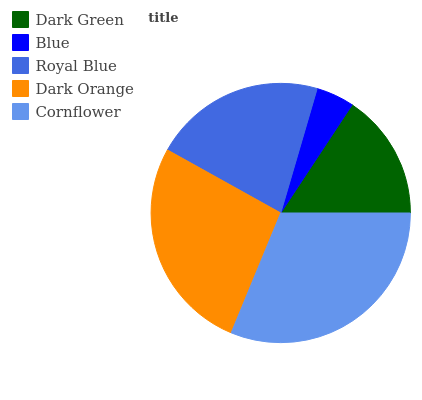Is Blue the minimum?
Answer yes or no. Yes. Is Cornflower the maximum?
Answer yes or no. Yes. Is Royal Blue the minimum?
Answer yes or no. No. Is Royal Blue the maximum?
Answer yes or no. No. Is Royal Blue greater than Blue?
Answer yes or no. Yes. Is Blue less than Royal Blue?
Answer yes or no. Yes. Is Blue greater than Royal Blue?
Answer yes or no. No. Is Royal Blue less than Blue?
Answer yes or no. No. Is Royal Blue the high median?
Answer yes or no. Yes. Is Royal Blue the low median?
Answer yes or no. Yes. Is Dark Green the high median?
Answer yes or no. No. Is Dark Orange the low median?
Answer yes or no. No. 